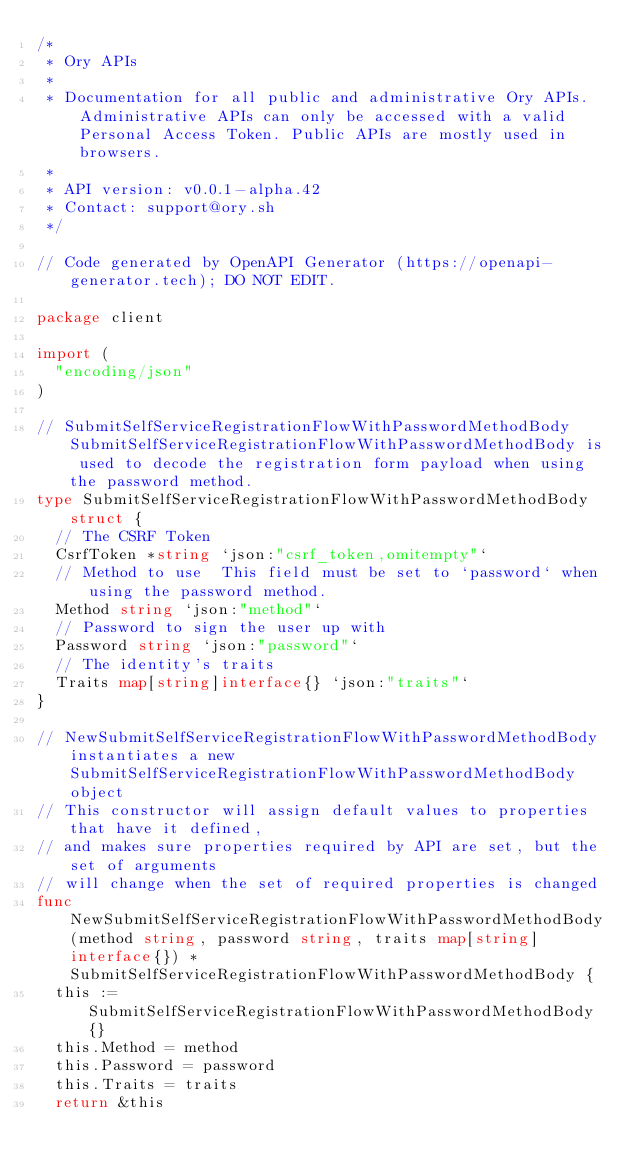<code> <loc_0><loc_0><loc_500><loc_500><_Go_>/*
 * Ory APIs
 *
 * Documentation for all public and administrative Ory APIs. Administrative APIs can only be accessed with a valid Personal Access Token. Public APIs are mostly used in browsers. 
 *
 * API version: v0.0.1-alpha.42
 * Contact: support@ory.sh
 */

// Code generated by OpenAPI Generator (https://openapi-generator.tech); DO NOT EDIT.

package client

import (
	"encoding/json"
)

// SubmitSelfServiceRegistrationFlowWithPasswordMethodBody SubmitSelfServiceRegistrationFlowWithPasswordMethodBody is used to decode the registration form payload when using the password method.
type SubmitSelfServiceRegistrationFlowWithPasswordMethodBody struct {
	// The CSRF Token
	CsrfToken *string `json:"csrf_token,omitempty"`
	// Method to use  This field must be set to `password` when using the password method.
	Method string `json:"method"`
	// Password to sign the user up with
	Password string `json:"password"`
	// The identity's traits
	Traits map[string]interface{} `json:"traits"`
}

// NewSubmitSelfServiceRegistrationFlowWithPasswordMethodBody instantiates a new SubmitSelfServiceRegistrationFlowWithPasswordMethodBody object
// This constructor will assign default values to properties that have it defined,
// and makes sure properties required by API are set, but the set of arguments
// will change when the set of required properties is changed
func NewSubmitSelfServiceRegistrationFlowWithPasswordMethodBody(method string, password string, traits map[string]interface{}) *SubmitSelfServiceRegistrationFlowWithPasswordMethodBody {
	this := SubmitSelfServiceRegistrationFlowWithPasswordMethodBody{}
	this.Method = method
	this.Password = password
	this.Traits = traits
	return &this</code> 